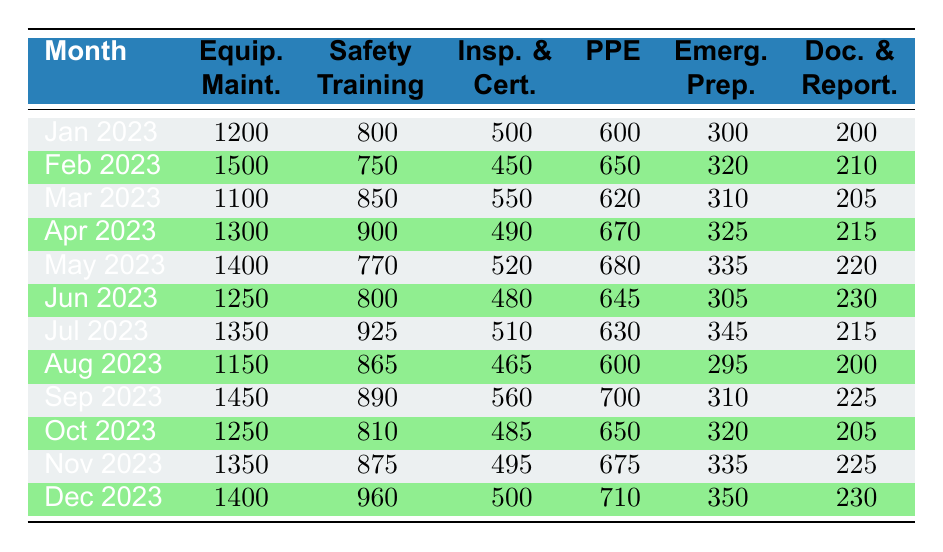What was the highest expenditure on Equipment Maintenance in 2023? The highest value for Equipment Maintenance can be found by looking through the values in that column. Scanning the months, the maximum value is 1500 for February 2023.
Answer: 1500 What was the total expenditure on Personal Protection Equipment for 2023? To find the total for Personal Protection Equipment, I will add all the values together: 600 + 650 + 620 + 670 + 680 + 645 + 630 + 600 + 700 + 650 + 675 + 710 = 7,215.
Answer: 7215 Was there any month in 2023 with expenditures exceeding 1000 for Inspections and Certifications? I will check each month in the Inspections and Certifications column to see if any value is above 1000. After reviewing the values, all are below 1000; thus, no month has expenditures exceeding that amount.
Answer: No What is the average expenditure on Safety Training across all months? To find the average, I sum the Safety Training expenditures: 800 + 750 + 850 + 900 + 770 + 800 + 925 + 865 + 890 + 810 + 875 + 960 = 10,650, and divide by 12 (the total months): 10,650 / 12 = 887.5.
Answer: 887.5 In which month did the total safety compliance expenditure last reach its peak? I will sum all the specific expenditure categories for each month to find the month with the highest total expenditure. For example, in December 2023: 1400 + 960 + 500 + 710 + 350 + 230 = 4140. After tallying for other months, December 2023 had the highest total expenditure.
Answer: December 2023 What was the difference in expenditures for Documentation and Reporting between January and December 2023? I will look at the values for Documentation and Reporting for both months: January is 200, and December is 230. Thus, the difference is 230 - 200 = 30.
Answer: 30 Did the expenditures for Emergency Preparedness increase from January to December 2023? I will check the values for Emergency Preparedness in both months: January is 300, while December is 350. Since 350 is greater than 300, the expenditures did indeed increase.
Answer: Yes Which month had the lowest expenditure on Safety Training and what was the amount? To find the lowest month for Safety Training, I will check the values in that column. Looking through the months, February 2023 had the lowest expenditure at 750.
Answer: February 2023, 750 